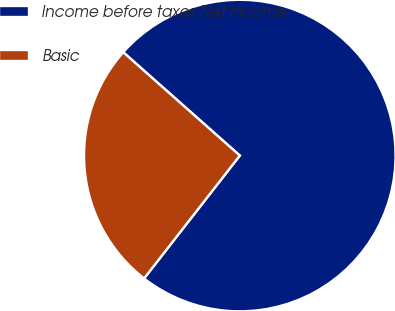Convert chart to OTSL. <chart><loc_0><loc_0><loc_500><loc_500><pie_chart><fcel>Income before taxes Net income<fcel>Basic<nl><fcel>73.99%<fcel>26.01%<nl></chart> 